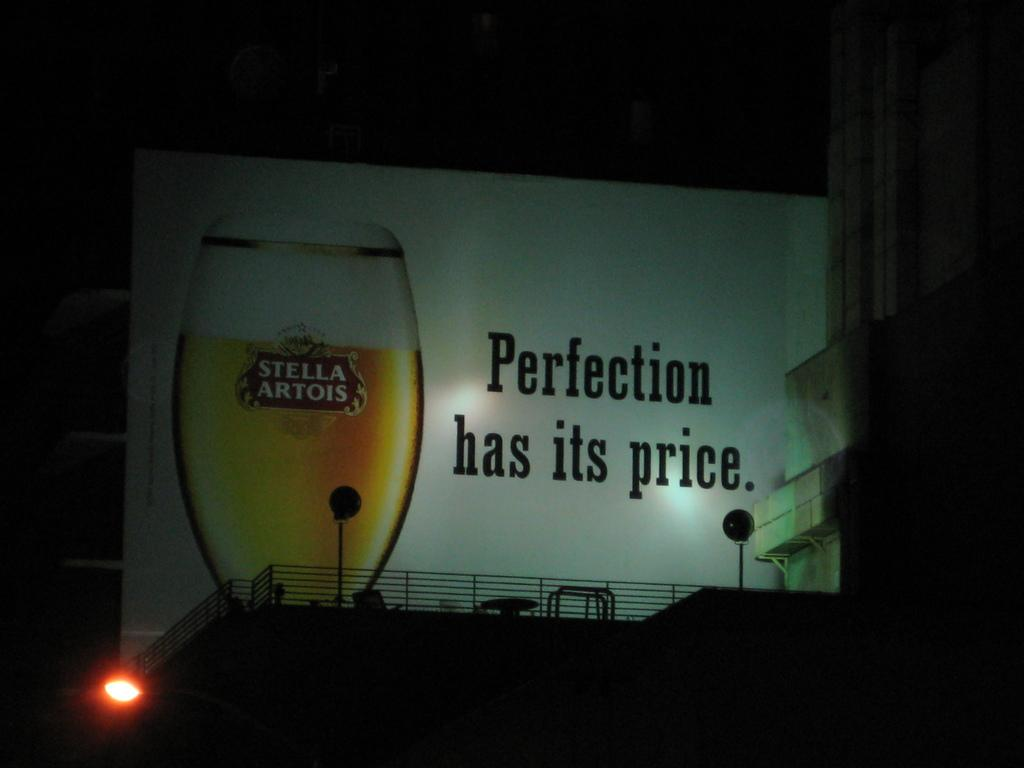<image>
Write a terse but informative summary of the picture. A billboard for Stella Artois reads "Perfection has its price." 